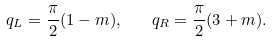<formula> <loc_0><loc_0><loc_500><loc_500>q _ { L } = \frac { \pi } { 2 } ( 1 - m ) , \quad q _ { R } = \frac { \pi } { 2 } ( 3 + m ) .</formula> 